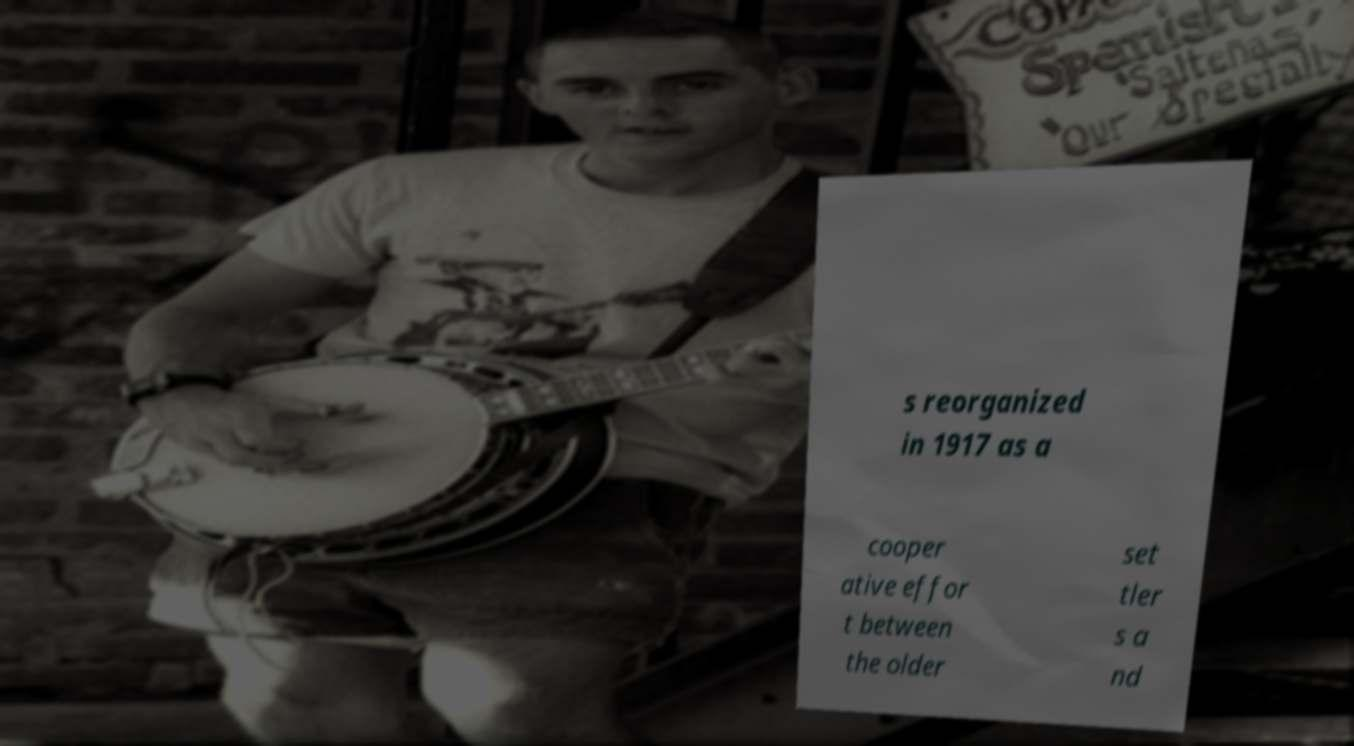There's text embedded in this image that I need extracted. Can you transcribe it verbatim? s reorganized in 1917 as a cooper ative effor t between the older set tler s a nd 